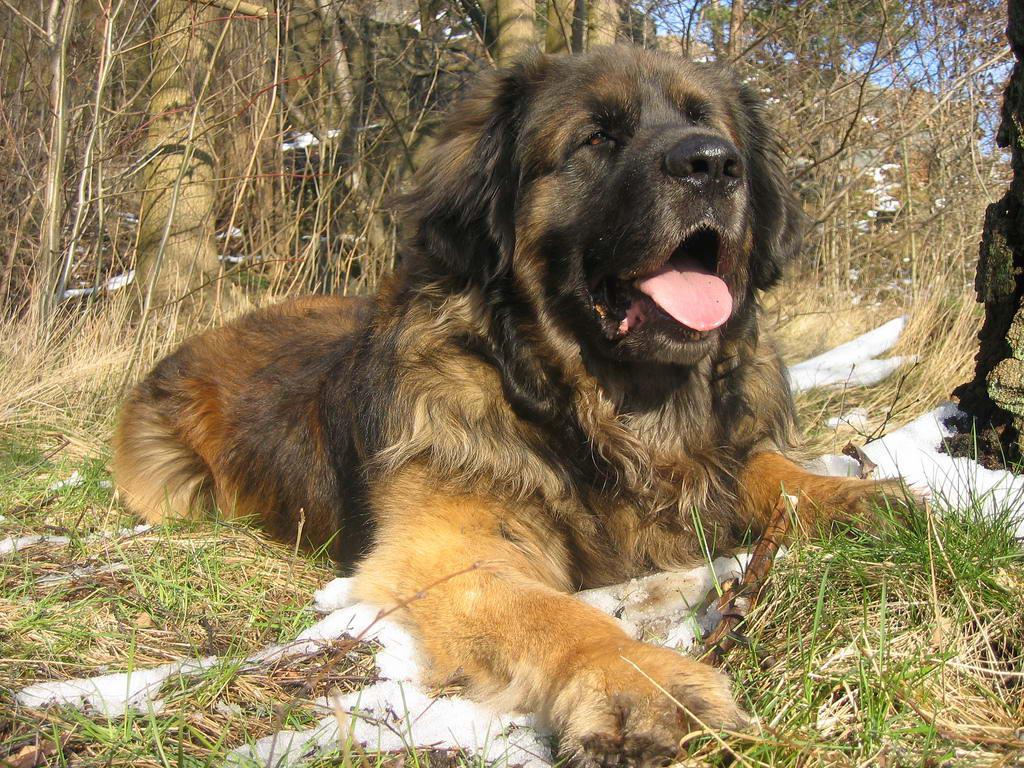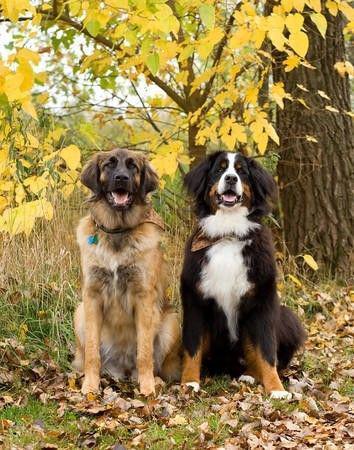The first image is the image on the left, the second image is the image on the right. For the images shown, is this caption "There are exactly two dogs lying in the image on the right." true? Answer yes or no. No. 